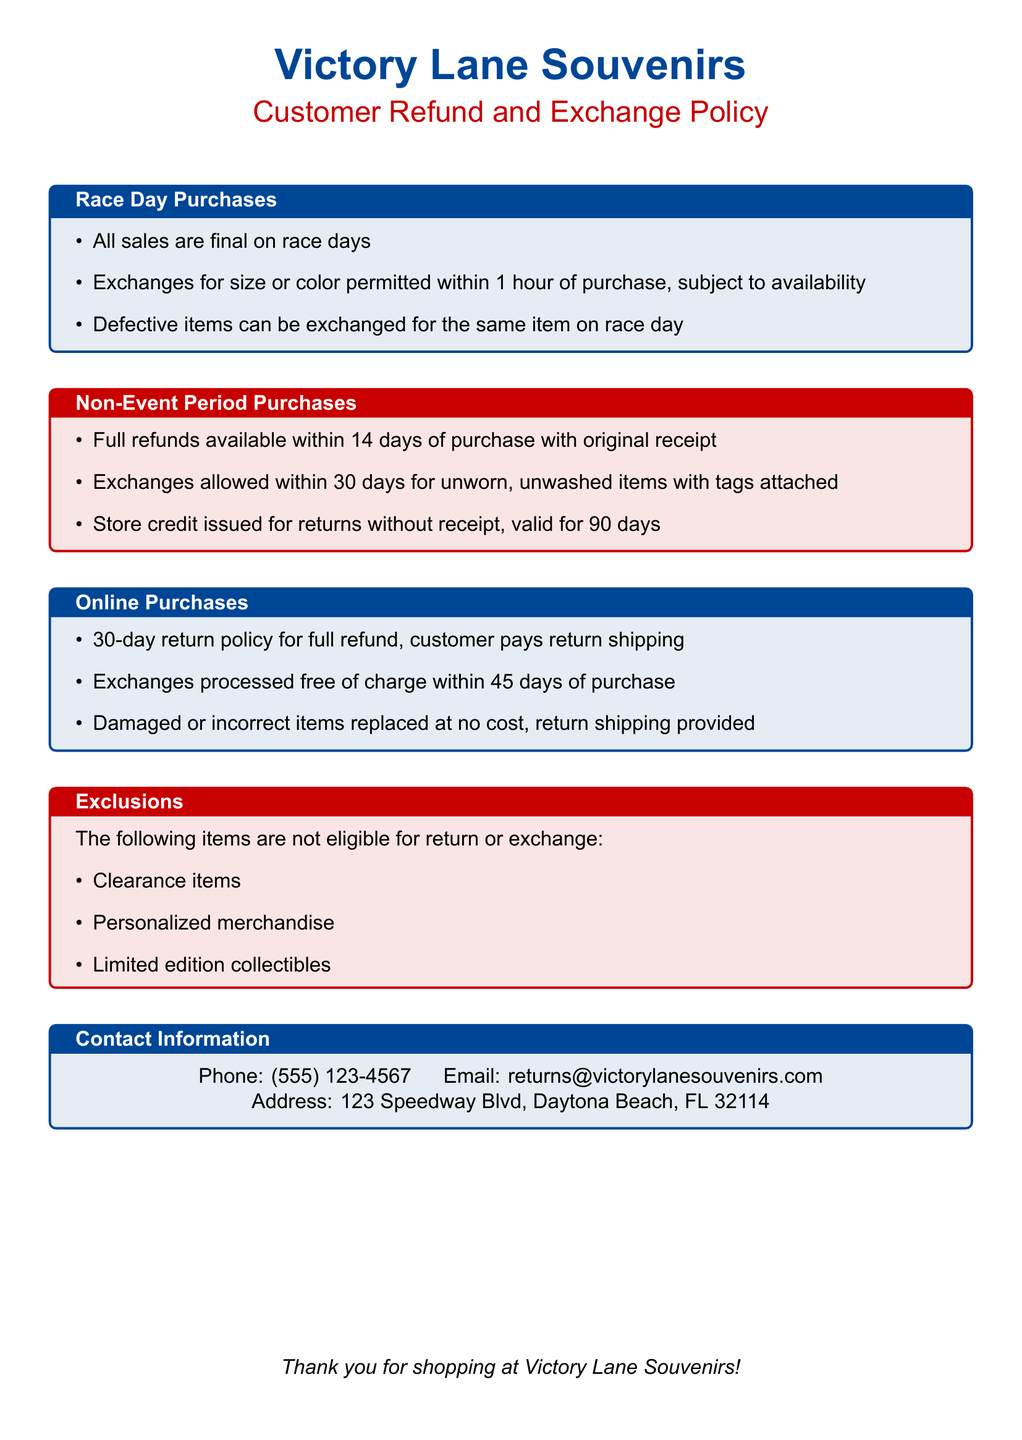What is the policy for race day sales? The document states that all sales are final on race days.
Answer: All sales are final on race days What is the time limit for exchanges on race day? The document mentions that exchanges for size or color are permitted within 1 hour of purchase.
Answer: 1 hour What is the refund period for non-event purchases? According to the document, full refunds are available within 14 days of purchase.
Answer: 14 days What condition must items meet for exchange during non-event periods? The document specifies that exchanges are allowed within 30 days for unworn, unwashed items with tags attached.
Answer: Unworn, unwashed items with tags attached Are clearance items eligible for return? The document lists clearance items as exclusions for return or exchange.
Answer: No What number can customers call for inquiries? The contact information section provides a phone number for customer inquiries.
Answer: (555) 123-4567 How long is the online return policy valid for full refunds? The document indicates that the online return policy allows for a 30-day period for full refund.
Answer: 30 days What items are not eligible for exchange? The document lists personalized merchandise as one of the excluded items for return or exchange.
Answer: Personalized merchandise 